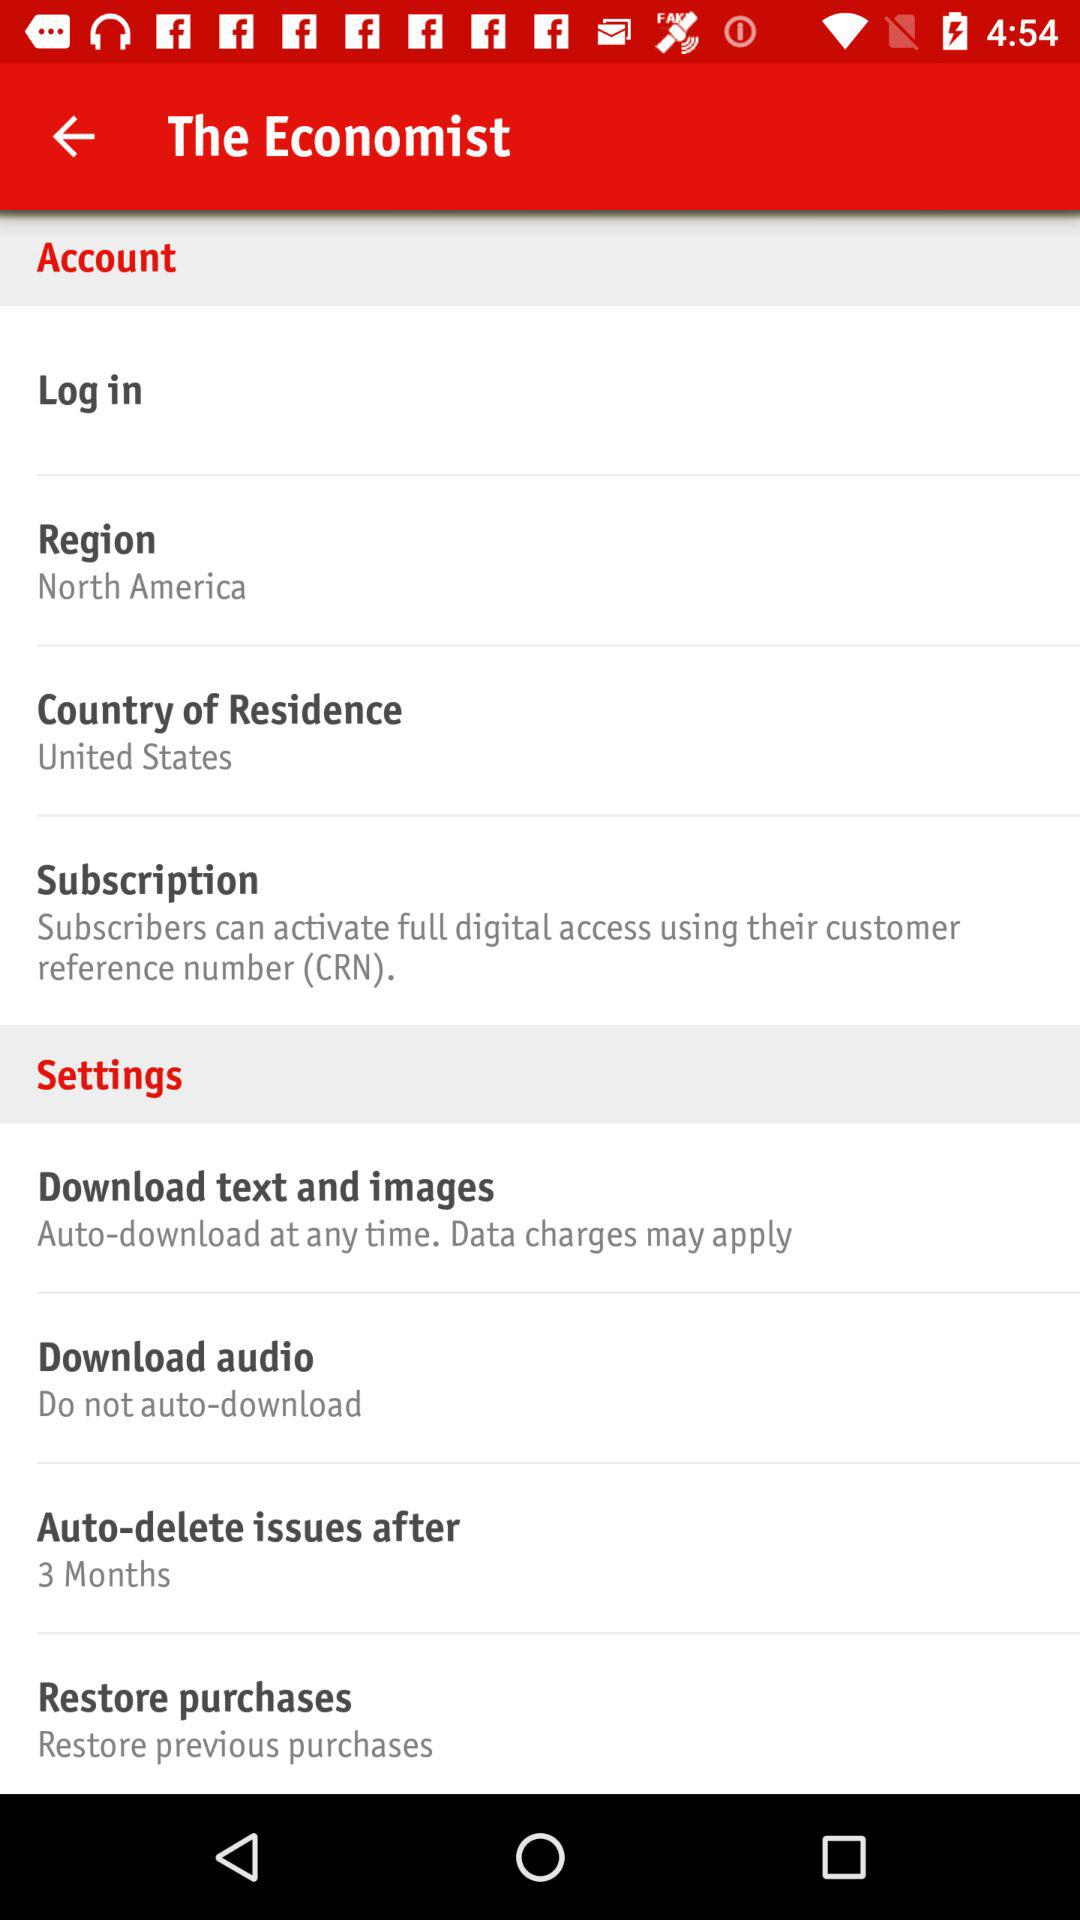How many months are selected in "Auto-delete issues after"? In "Auto-delete issues after" it is selected 3 months. 